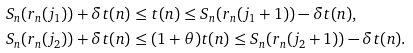<formula> <loc_0><loc_0><loc_500><loc_500>S _ { n } ( r _ { n } ( j _ { 1 } ) ) + \delta t ( n ) & \leq t ( n ) \leq S _ { n } ( r _ { n } ( j _ { 1 } + 1 ) ) - \delta t ( n ) , \\ S _ { n } ( r _ { n } ( j _ { 2 } ) ) + \delta t ( n ) & \leq ( 1 + \theta ) t ( n ) \leq S _ { n } ( r _ { n } ( j _ { 2 } + 1 ) ) - \delta t ( n ) .</formula> 